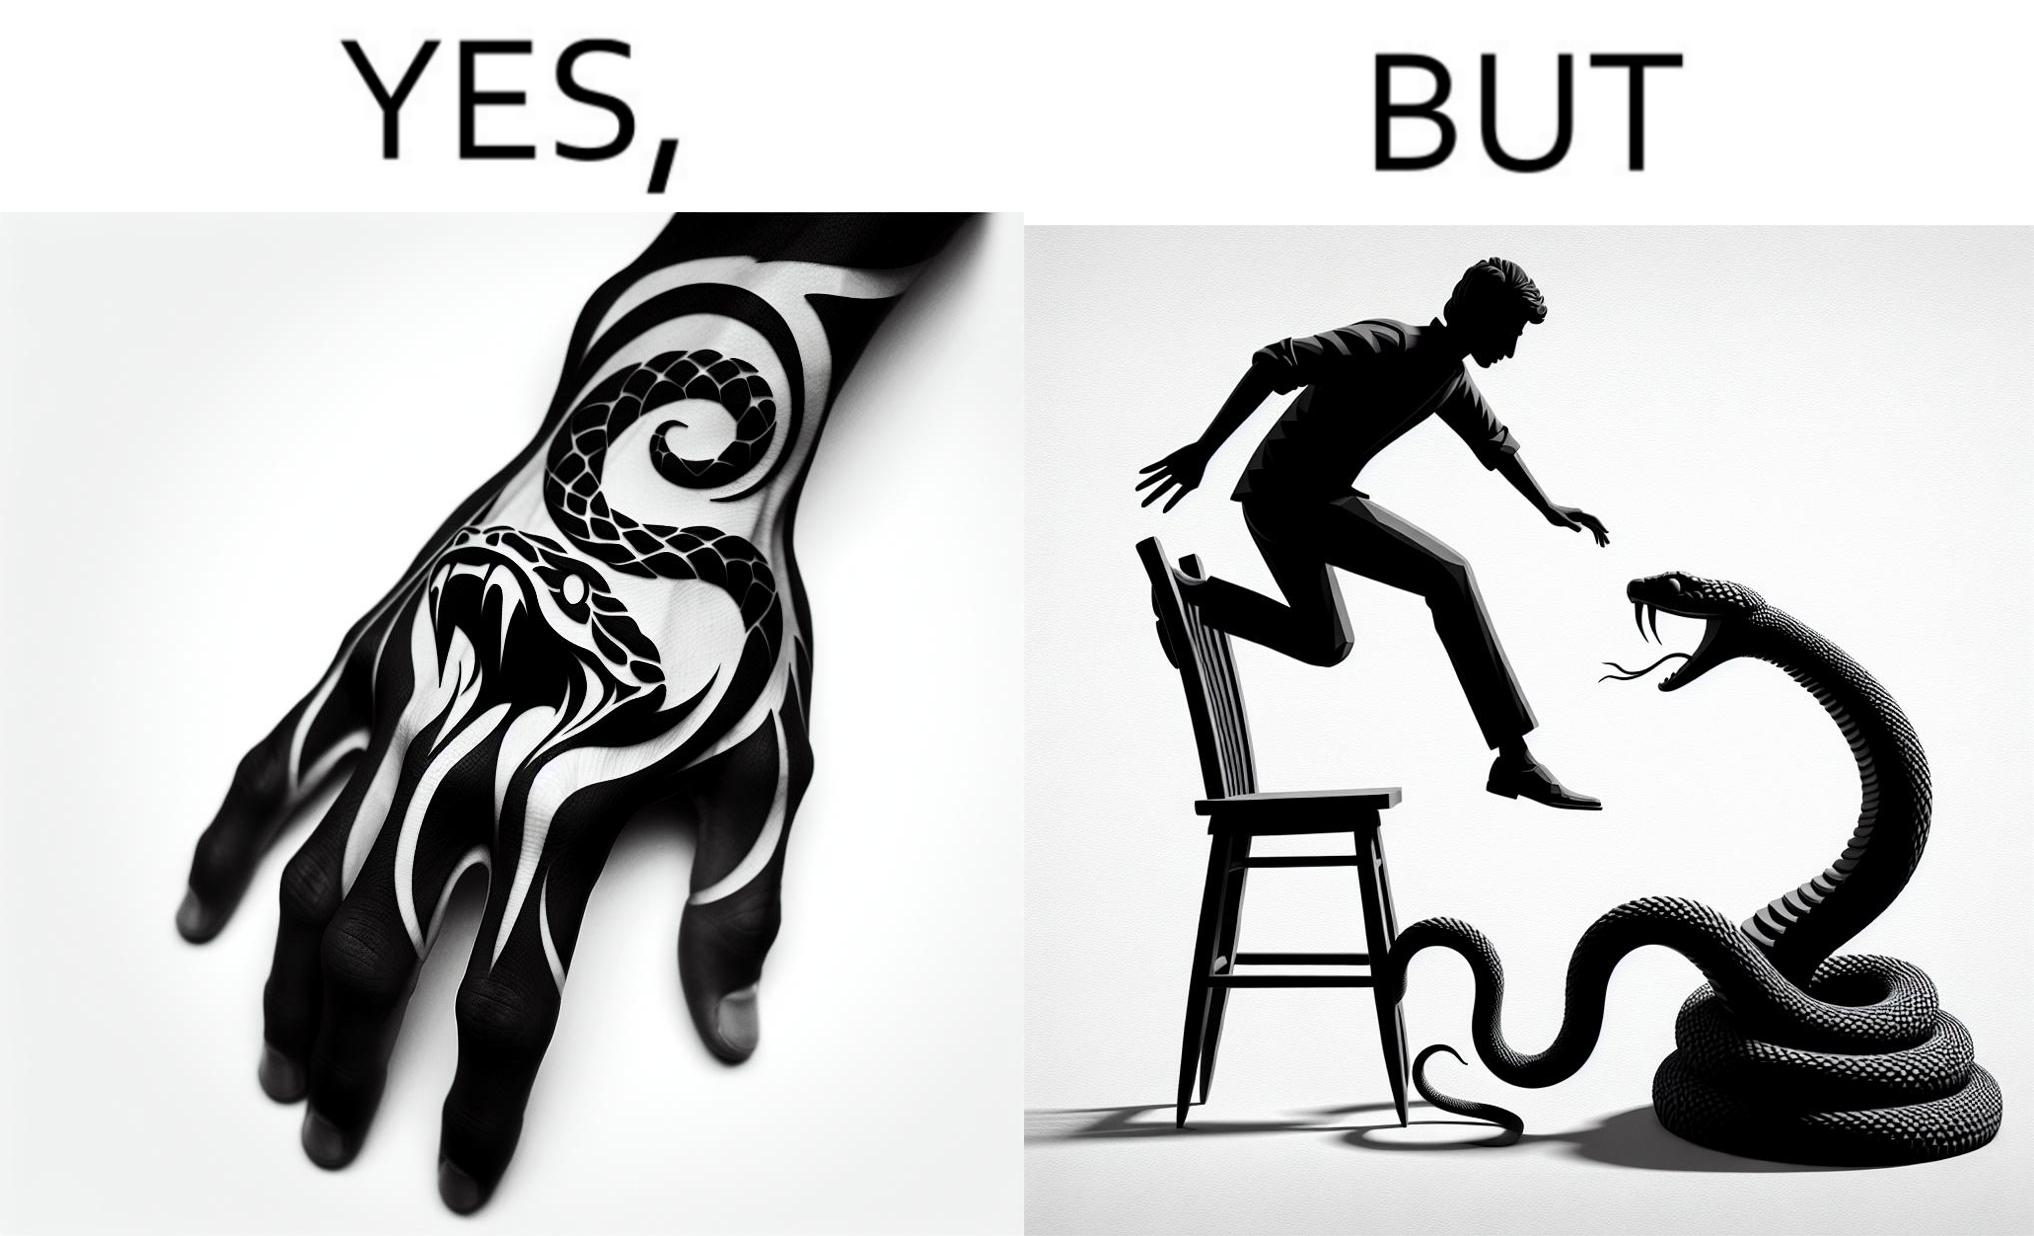Does this image contain satire or humor? Yes, this image is satirical. 